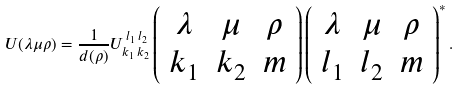Convert formula to latex. <formula><loc_0><loc_0><loc_500><loc_500>U ( \lambda \mu \rho ) = { \frac { 1 } { d ( \rho ) } } U _ { k _ { 1 } \, k _ { 2 } } ^ { \, l _ { 1 } \, l _ { 2 } } \left ( \begin{array} { c c c } { \lambda } & { \mu } & { \rho } \\ { { k _ { 1 } } } & { { k _ { 2 } } } & { m } \end{array} \right ) \left ( \begin{array} { c c c } { \lambda } & { \mu } & { \rho } \\ { { l _ { 1 } } } & { { l _ { 2 } } } & { m } \end{array} \right ) ^ { \ast } .</formula> 